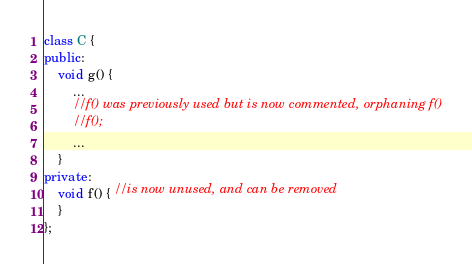<code> <loc_0><loc_0><loc_500><loc_500><_C++_>class C {
public:
	void g() {
		...
		//f() was previously used but is now commented, orphaning f()
		//f();
		...
	}
private:
	void f() { //is now unused, and can be removed
	}
};
</code> 